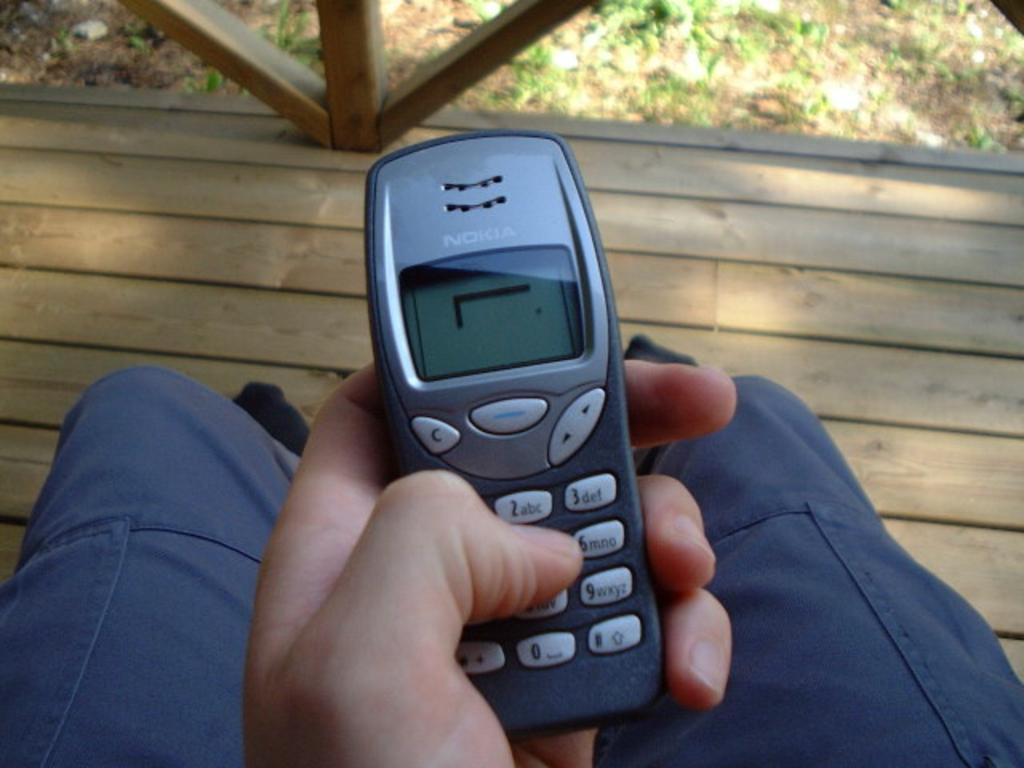Please provide a concise description of this image. In this picture I can see a person holding a mobile, and in the background there is grass and wooden pathway. 